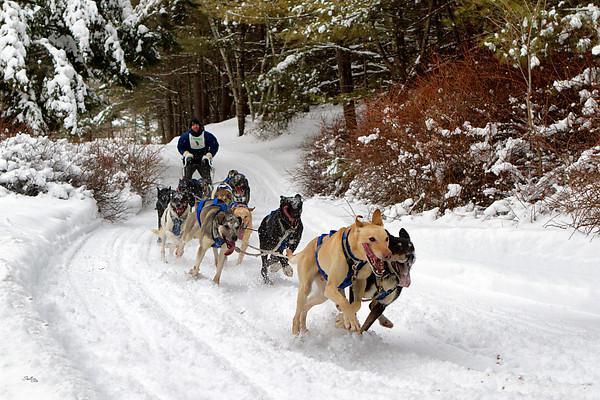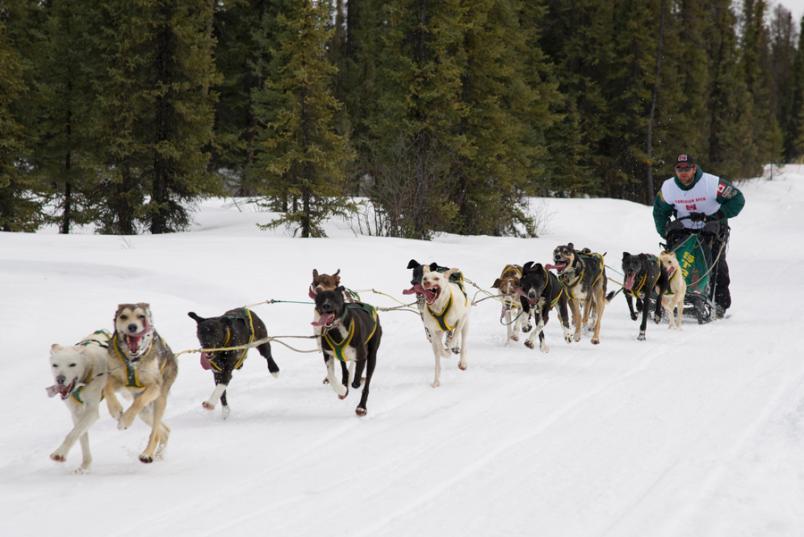The first image is the image on the left, the second image is the image on the right. Assess this claim about the two images: "All the dogs are moving forward.". Correct or not? Answer yes or no. Yes. The first image is the image on the left, the second image is the image on the right. Evaluate the accuracy of this statement regarding the images: "The dog-pulled sleds in the left and right images move forward over snow at a leftward angle.". Is it true? Answer yes or no. No. 